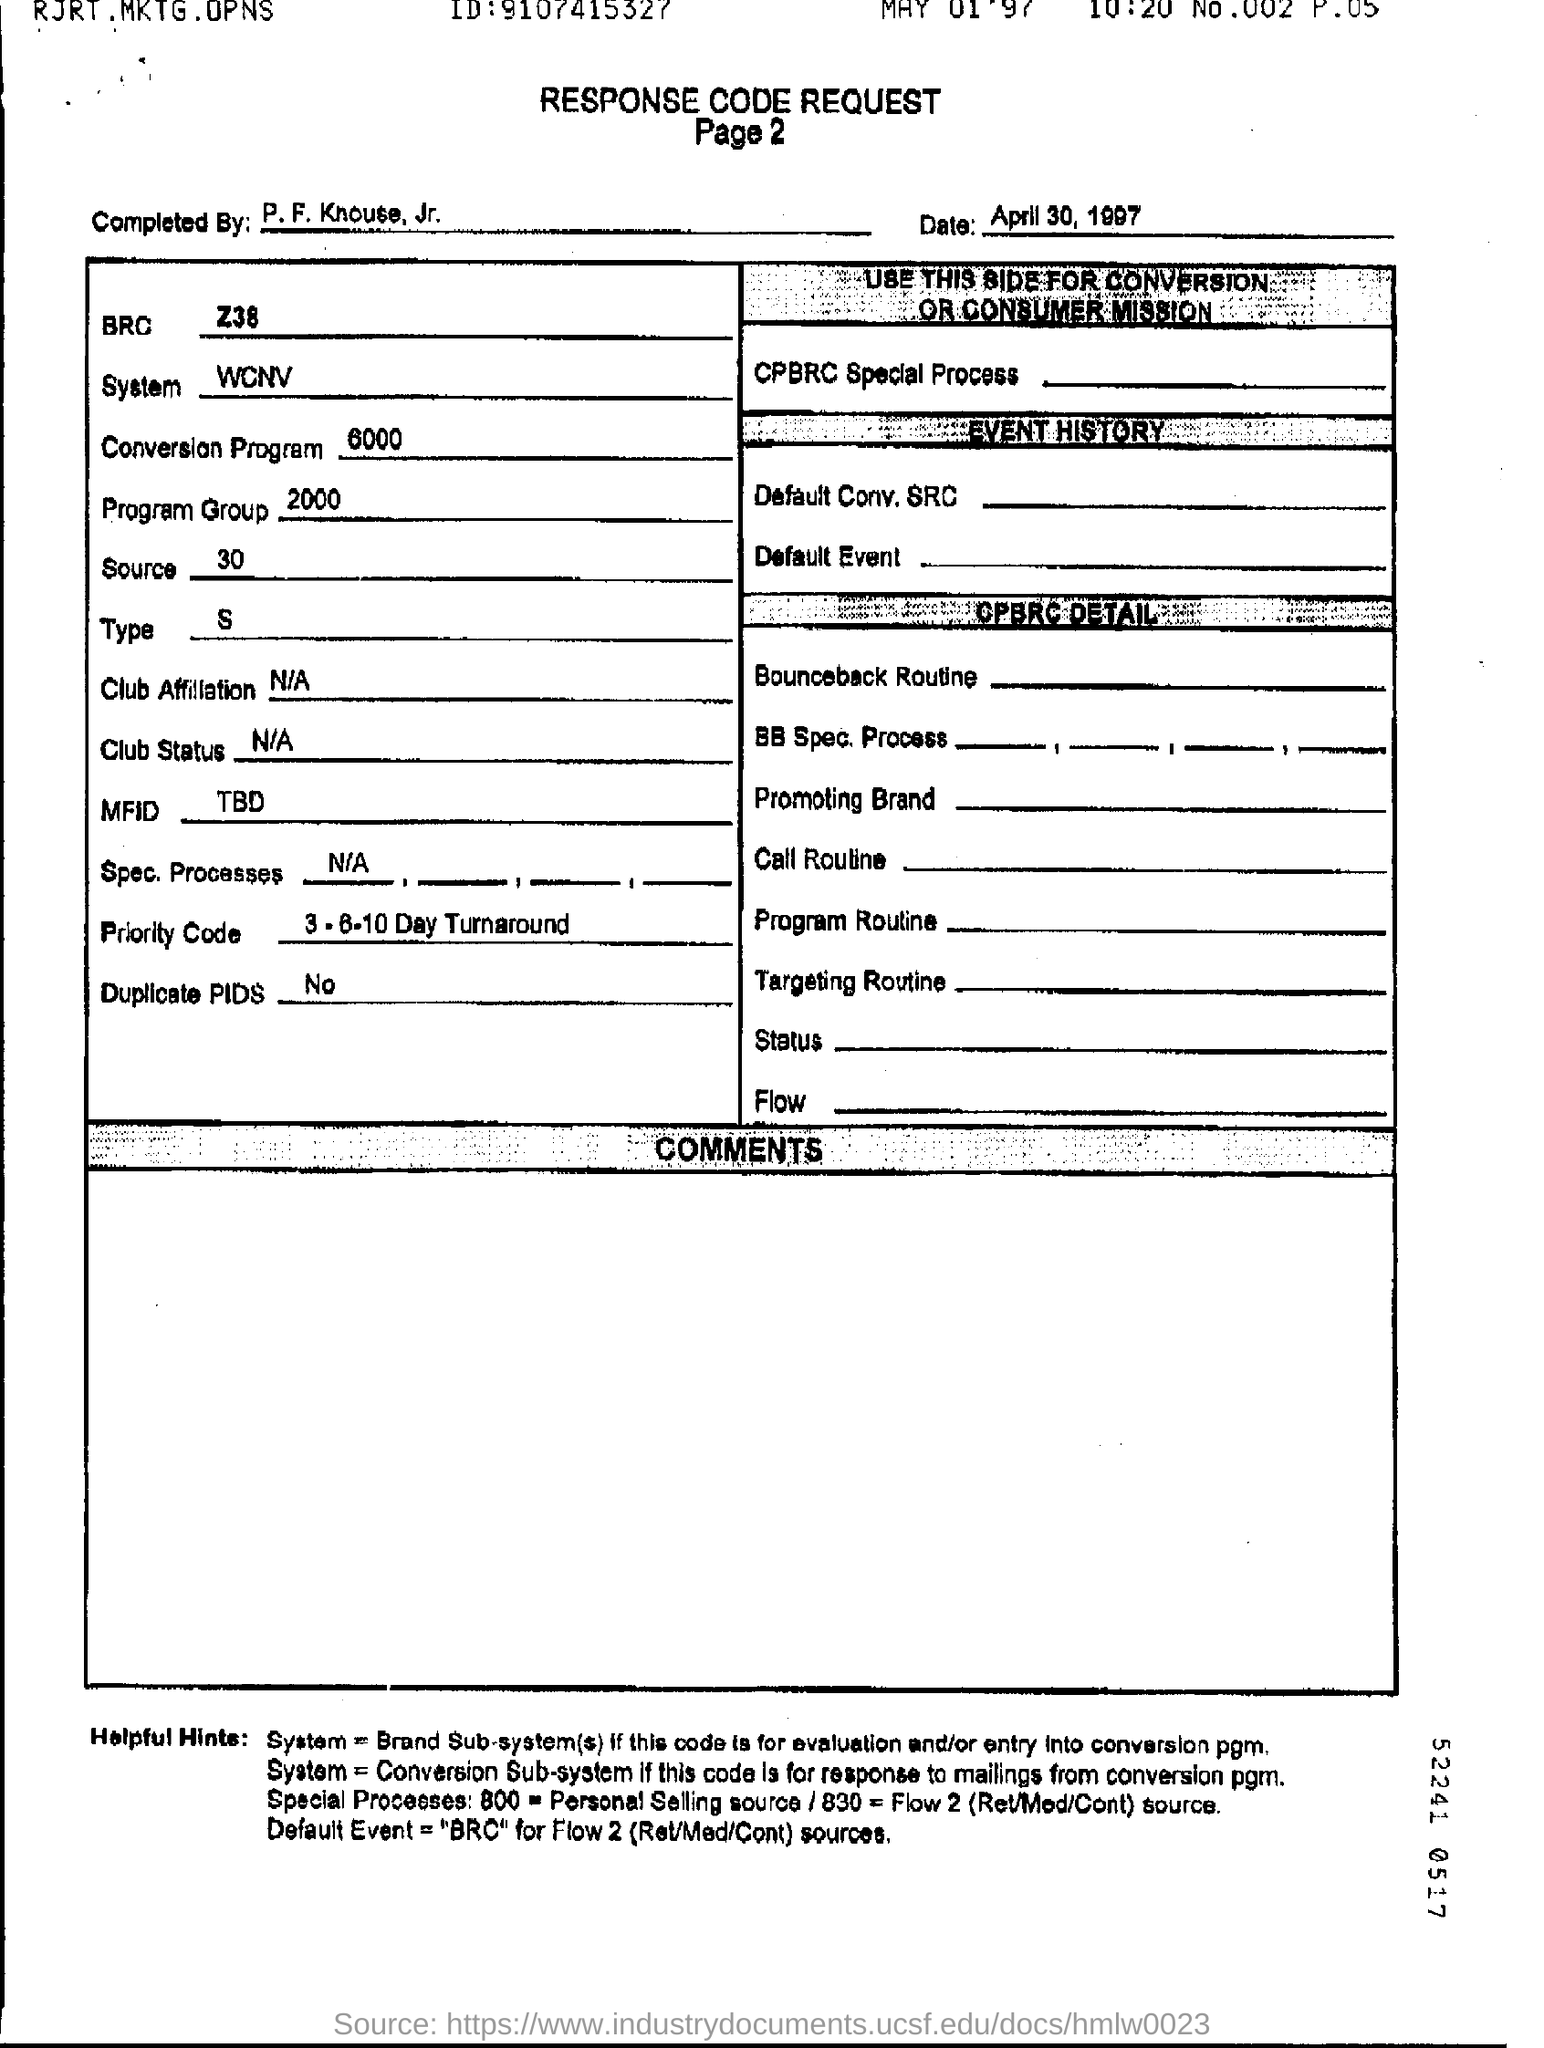By whom this response code sheet was completed?
Provide a short and direct response. P.F.Knouse.jr. Is there any duplicate PIDS?
Your answer should be compact. No. 